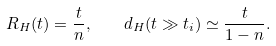<formula> <loc_0><loc_0><loc_500><loc_500>R _ { H } ( t ) = \frac { t } { n } , \quad d _ { H } ( t \gg t _ { i } ) \simeq \frac { t } { 1 - n } .</formula> 